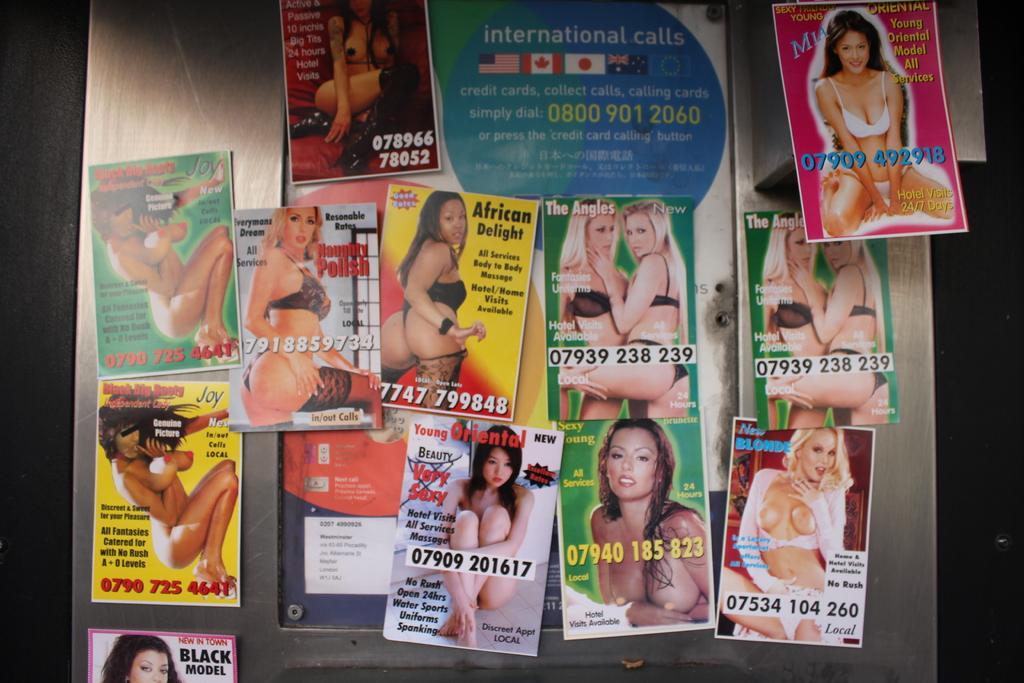Could you give a brief overview of what you see in this image? This image consists of so many magazines. On that there are pictures of women. 